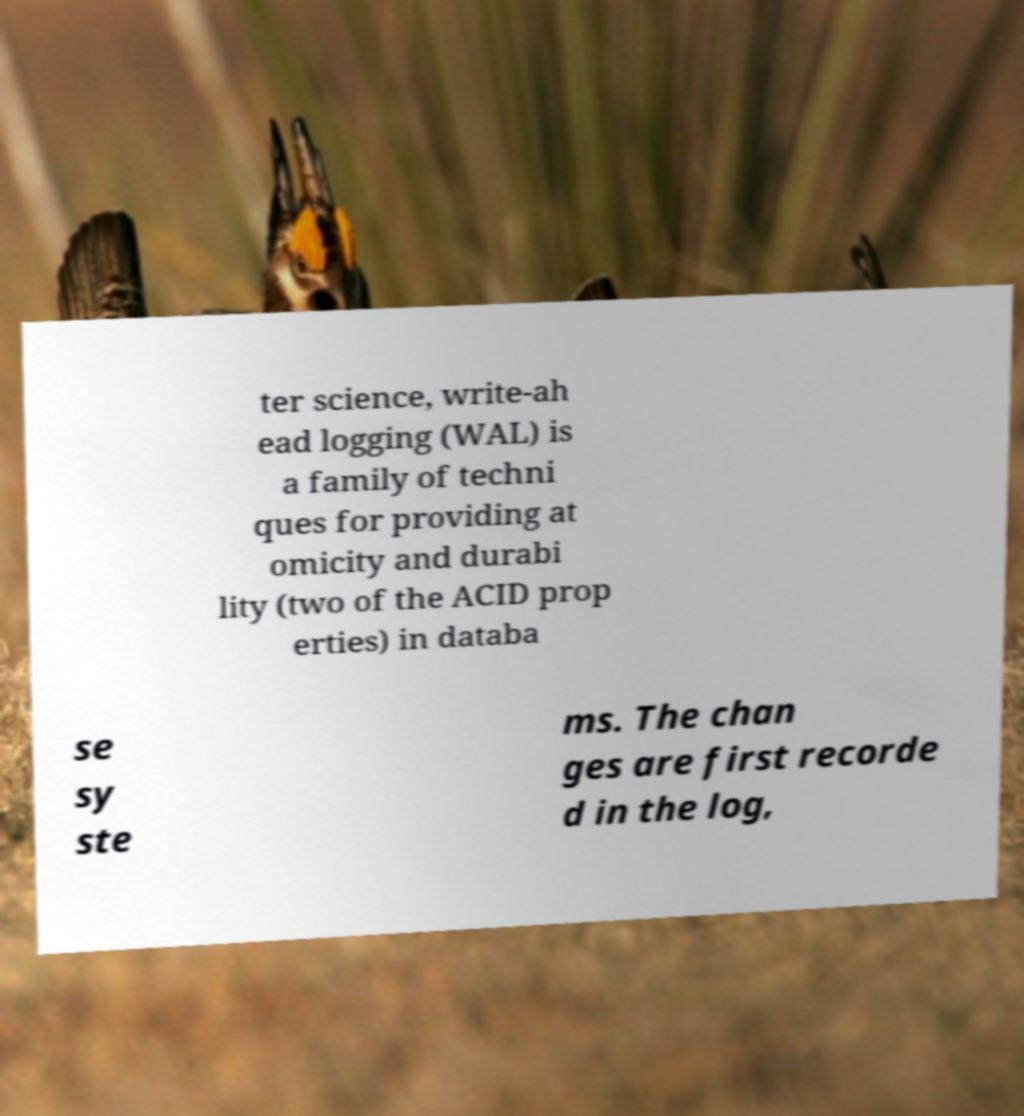For documentation purposes, I need the text within this image transcribed. Could you provide that? ter science, write-ah ead logging (WAL) is a family of techni ques for providing at omicity and durabi lity (two of the ACID prop erties) in databa se sy ste ms. The chan ges are first recorde d in the log, 